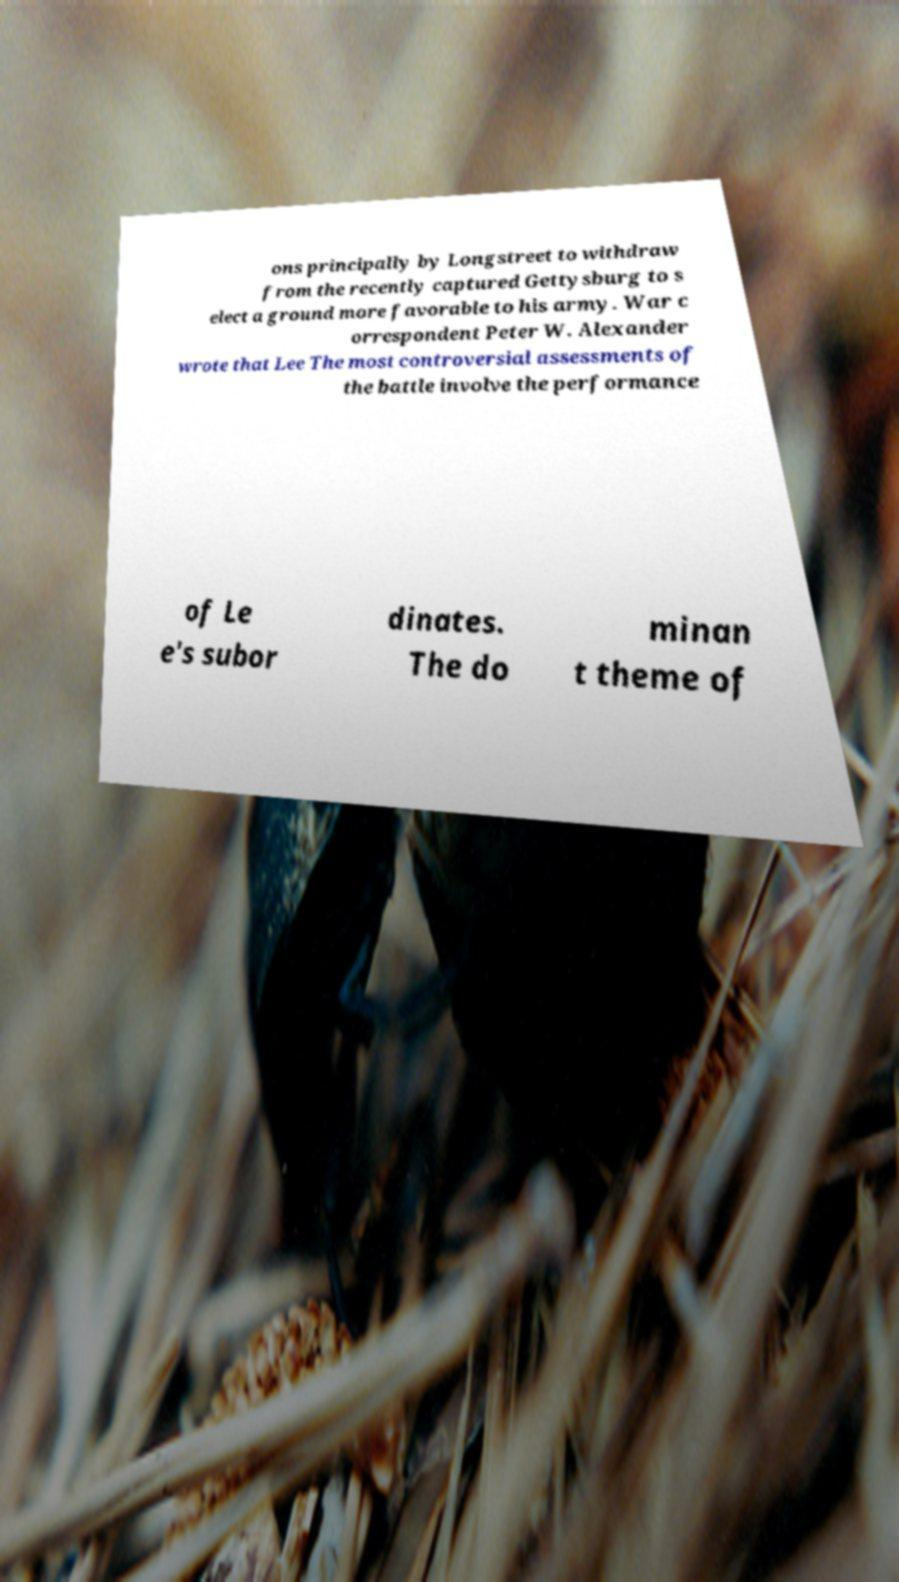What messages or text are displayed in this image? I need them in a readable, typed format. ons principally by Longstreet to withdraw from the recently captured Gettysburg to s elect a ground more favorable to his army. War c orrespondent Peter W. Alexander wrote that Lee The most controversial assessments of the battle involve the performance of Le e's subor dinates. The do minan t theme of 